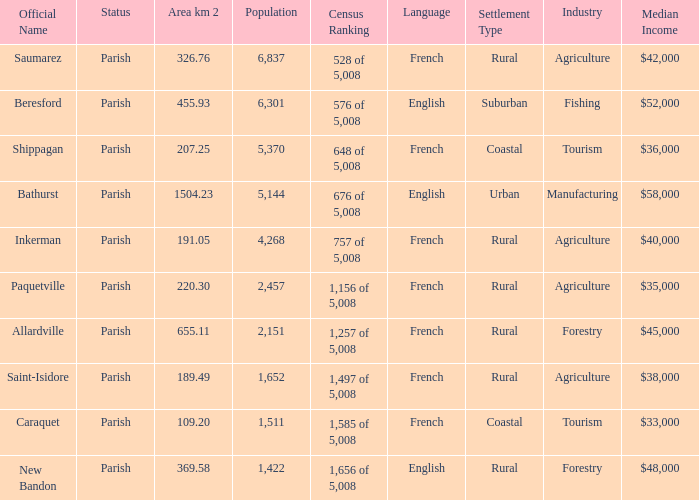What is the Population of the New Bandon Parish with an Area km 2 larger than 326.76? 1422.0. 